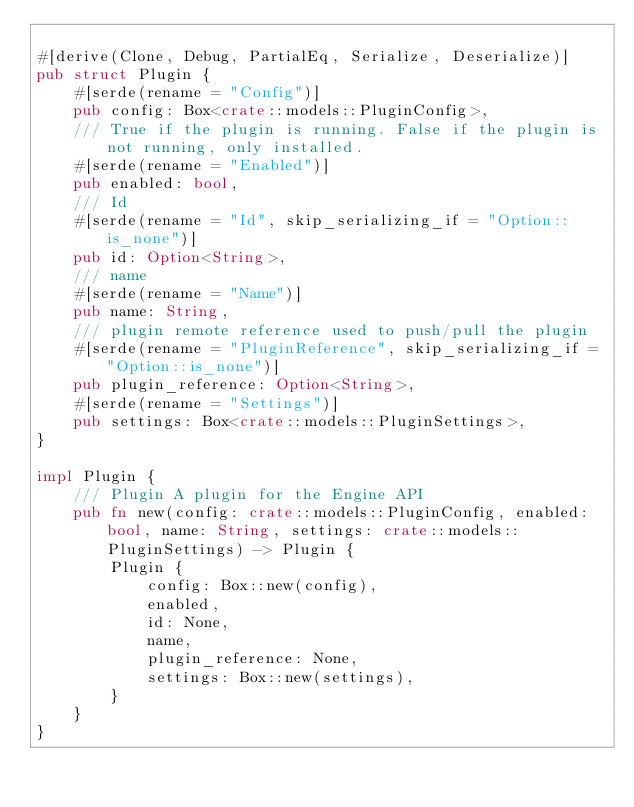Convert code to text. <code><loc_0><loc_0><loc_500><loc_500><_Rust_>
#[derive(Clone, Debug, PartialEq, Serialize, Deserialize)]
pub struct Plugin {
    #[serde(rename = "Config")]
    pub config: Box<crate::models::PluginConfig>,
    /// True if the plugin is running. False if the plugin is not running, only installed.
    #[serde(rename = "Enabled")]
    pub enabled: bool,
    /// Id
    #[serde(rename = "Id", skip_serializing_if = "Option::is_none")]
    pub id: Option<String>,
    /// name
    #[serde(rename = "Name")]
    pub name: String,
    /// plugin remote reference used to push/pull the plugin
    #[serde(rename = "PluginReference", skip_serializing_if = "Option::is_none")]
    pub plugin_reference: Option<String>,
    #[serde(rename = "Settings")]
    pub settings: Box<crate::models::PluginSettings>,
}

impl Plugin {
    /// Plugin A plugin for the Engine API
    pub fn new(config: crate::models::PluginConfig, enabled: bool, name: String, settings: crate::models::PluginSettings) -> Plugin {
        Plugin {
            config: Box::new(config),
            enabled,
            id: None,
            name,
            plugin_reference: None,
            settings: Box::new(settings),
        }
    }
}


</code> 